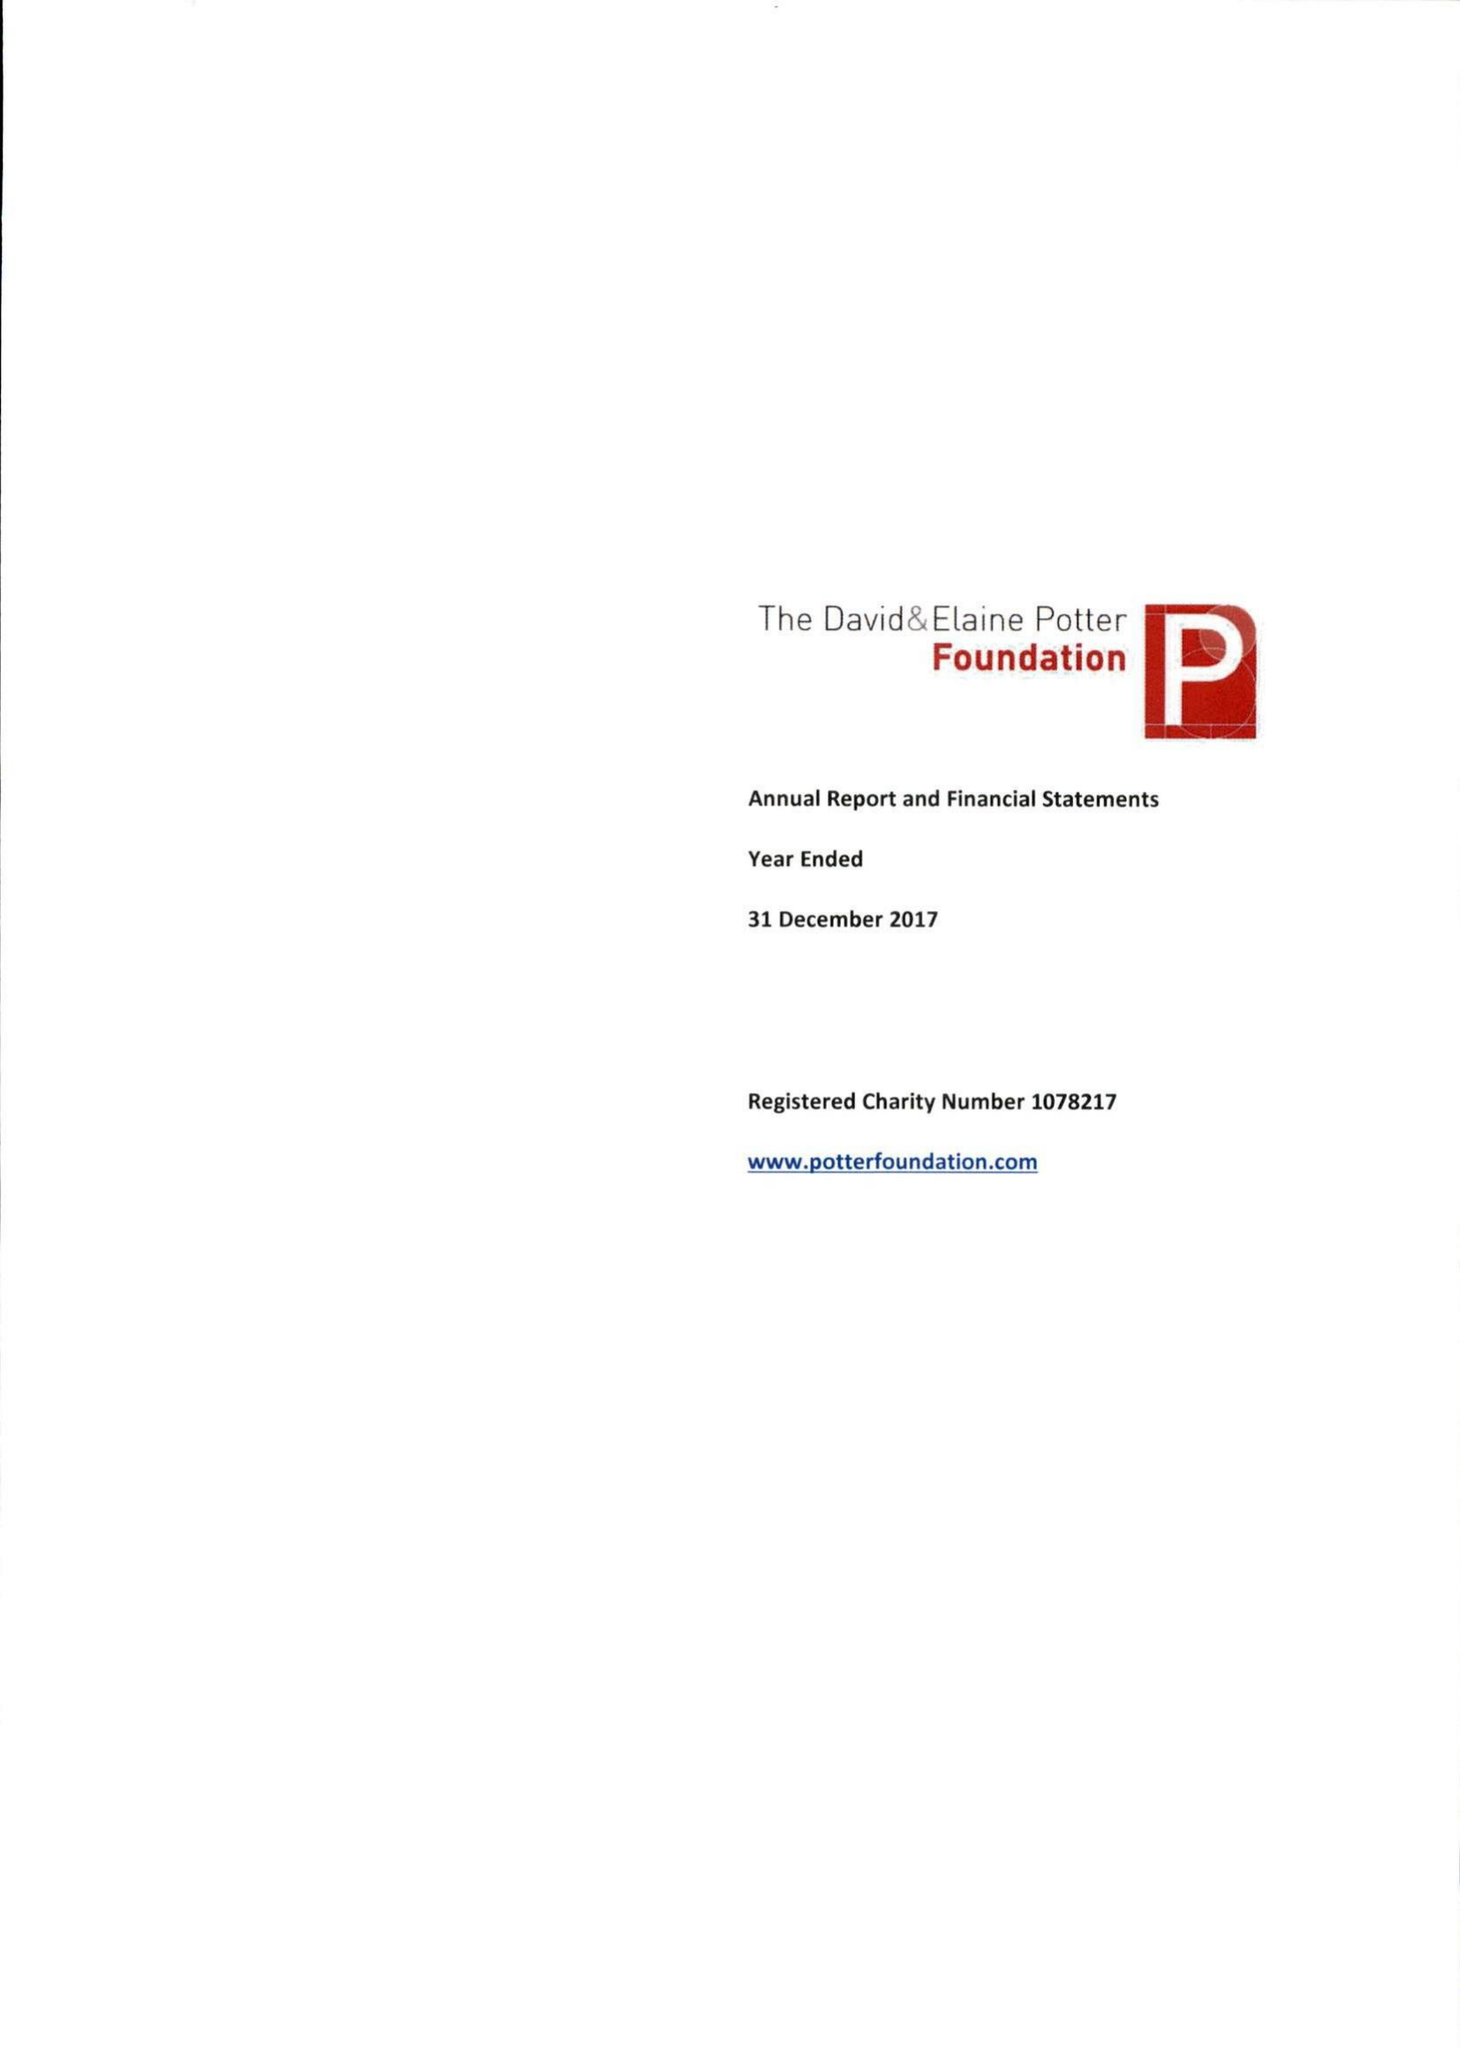What is the value for the address__post_town?
Answer the question using a single word or phrase. LONDON 